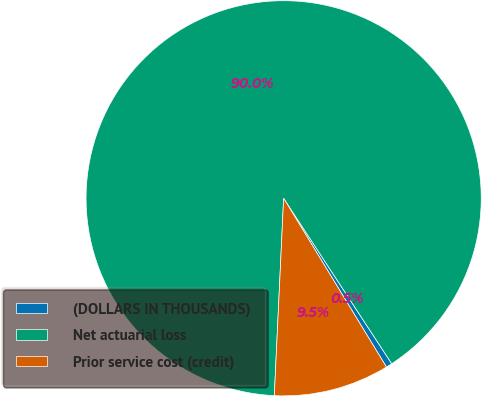<chart> <loc_0><loc_0><loc_500><loc_500><pie_chart><fcel>(DOLLARS IN THOUSANDS)<fcel>Net actuarial loss<fcel>Prior service cost (credit)<nl><fcel>0.5%<fcel>90.04%<fcel>9.46%<nl></chart> 